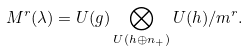Convert formula to latex. <formula><loc_0><loc_0><loc_500><loc_500>M ^ { r } ( \lambda ) = U ( g ) \bigotimes _ { U ( h \oplus n _ { + } ) } U ( h ) / m ^ { r } .</formula> 